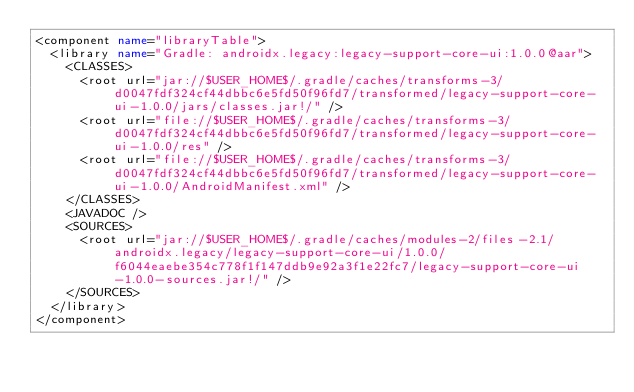Convert code to text. <code><loc_0><loc_0><loc_500><loc_500><_XML_><component name="libraryTable">
  <library name="Gradle: androidx.legacy:legacy-support-core-ui:1.0.0@aar">
    <CLASSES>
      <root url="jar://$USER_HOME$/.gradle/caches/transforms-3/d0047fdf324cf44dbbc6e5fd50f96fd7/transformed/legacy-support-core-ui-1.0.0/jars/classes.jar!/" />
      <root url="file://$USER_HOME$/.gradle/caches/transforms-3/d0047fdf324cf44dbbc6e5fd50f96fd7/transformed/legacy-support-core-ui-1.0.0/res" />
      <root url="file://$USER_HOME$/.gradle/caches/transforms-3/d0047fdf324cf44dbbc6e5fd50f96fd7/transformed/legacy-support-core-ui-1.0.0/AndroidManifest.xml" />
    </CLASSES>
    <JAVADOC />
    <SOURCES>
      <root url="jar://$USER_HOME$/.gradle/caches/modules-2/files-2.1/androidx.legacy/legacy-support-core-ui/1.0.0/f6044eaebe354c778f1f147ddb9e92a3f1e22fc7/legacy-support-core-ui-1.0.0-sources.jar!/" />
    </SOURCES>
  </library>
</component></code> 